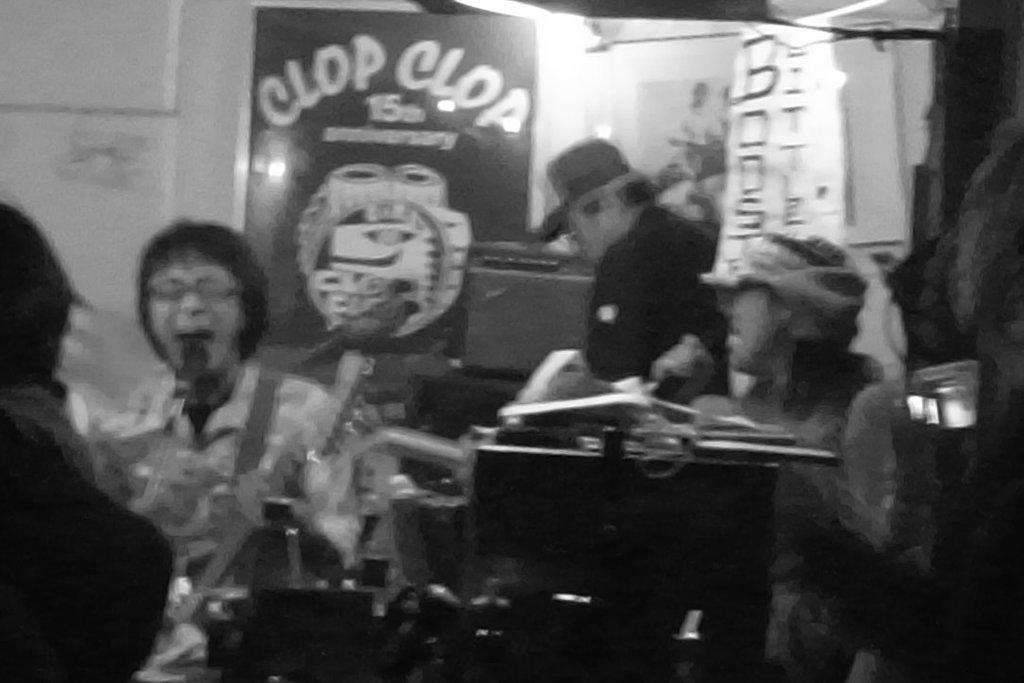Could you give a brief overview of what you see in this image? This is a black and white image. This picture looks slightly blurred. I can see few people sitting. I think this is a board. This looks like a banner. I can see few objects here. 